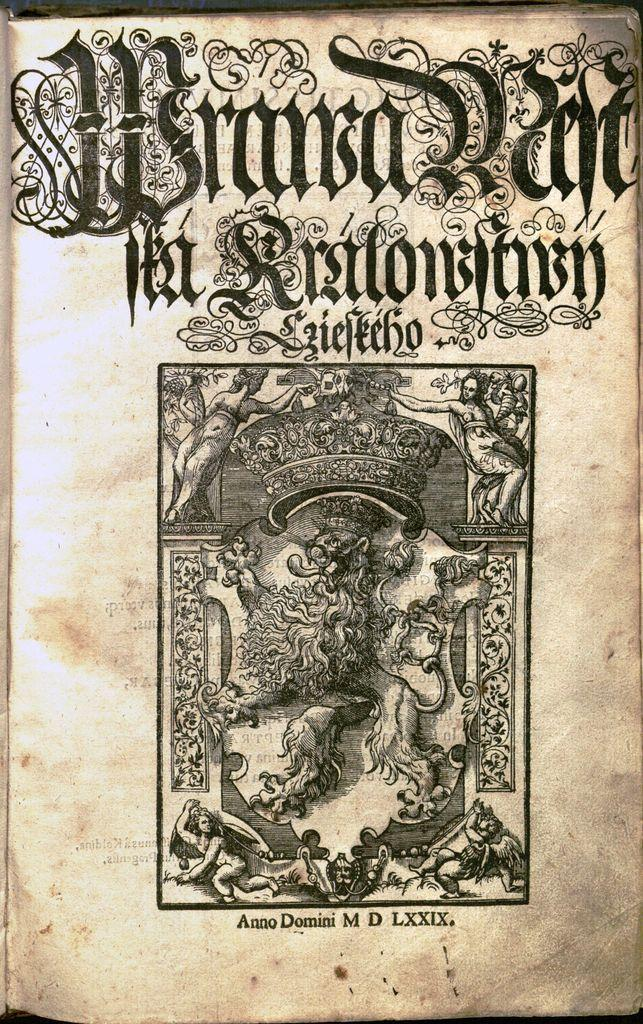Provide a one-sentence caption for the provided image. a title page of an ornate script and published in Anno Domini M D LXXIX. 